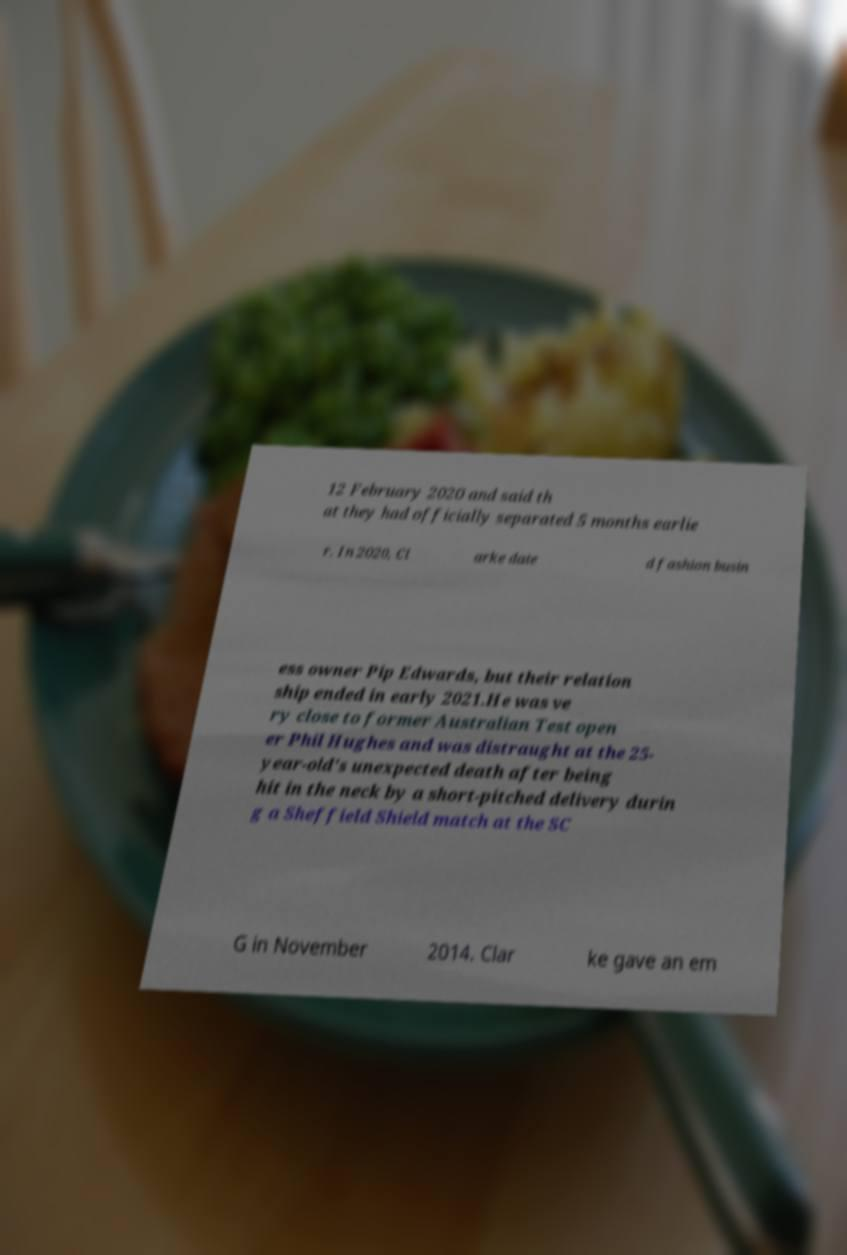Could you assist in decoding the text presented in this image and type it out clearly? 12 February 2020 and said th at they had officially separated 5 months earlie r. In 2020, Cl arke date d fashion busin ess owner Pip Edwards, but their relation ship ended in early 2021.He was ve ry close to former Australian Test open er Phil Hughes and was distraught at the 25- year-old's unexpected death after being hit in the neck by a short-pitched delivery durin g a Sheffield Shield match at the SC G in November 2014. Clar ke gave an em 